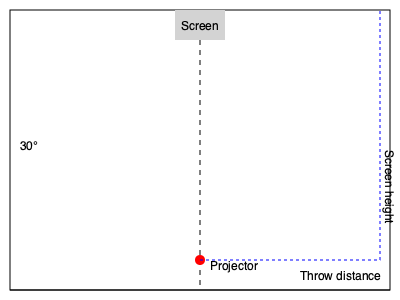In a new theater layout, you need to calculate the throw distance for a projector setup. The projector lens has a throw ratio of 1.6:1, and the desired screen width is 8 meters. The projection angle is 30° from horizontal. What is the required throw distance, and what will be the screen height? To solve this problem, we'll follow these steps:

1. Calculate the throw distance:
   - The throw ratio is 1.6:1, which means the throw distance is 1.6 times the screen width.
   - Throw distance = 1.6 × Screen width
   - Throw distance = 1.6 × 8 meters = 12.8 meters

2. Calculate the screen height:
   - We can use the tangent of the projection angle to find the screen height.
   - $\tan(30°) = \frac{\text{Screen height}}{\text{Throw distance}}$
   - $\text{Screen height} = \text{Throw distance} \times \tan(30°)$
   - $\text{Screen height} = 12.8 \times \tan(30°)$
   - $\text{Screen height} = 12.8 \times 0.5774 = 7.39$ meters

Therefore, the required throw distance is 12.8 meters, and the screen height will be 7.39 meters.
Answer: Throw distance: 12.8 m, Screen height: 7.39 m 